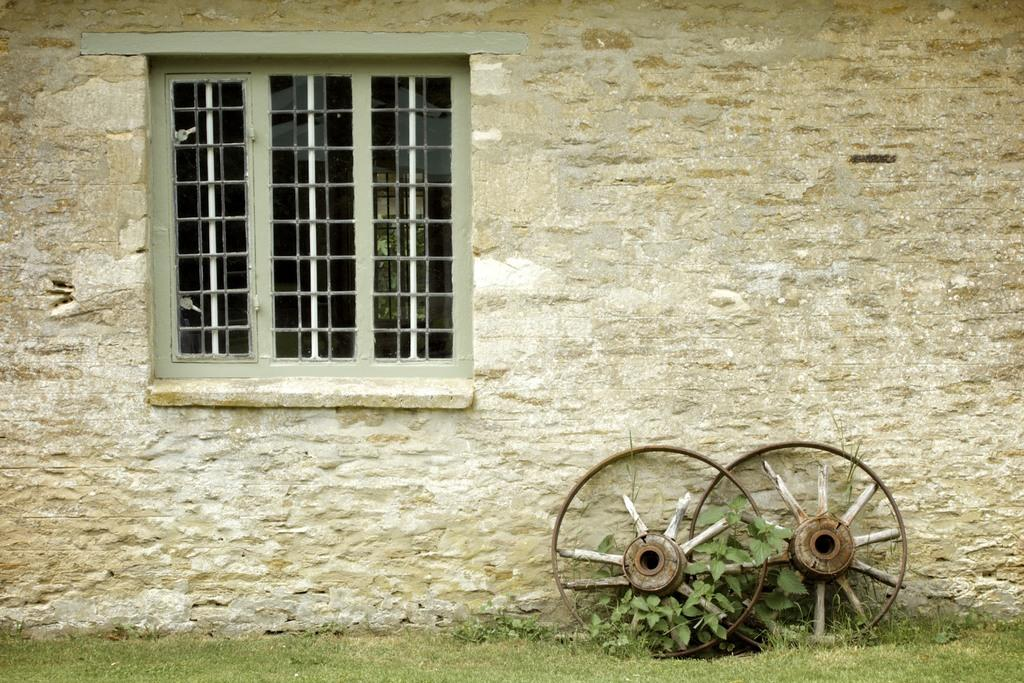What type of structure is visible in the image? There is a building wall in the image. Can you identify any openings in the building wall? Yes, there is a window in the image. What type of object is present with wheels? The wheels are visible in the image, but the object they belong to is not specified. What type of vegetation is visible in the image? There is a plant and grass visible in the image. How many passengers are visible in the image? There are no passengers present in the image. What type of pot is used to water the plant in the image? There is no pot visible in the image; only the plant is present. 